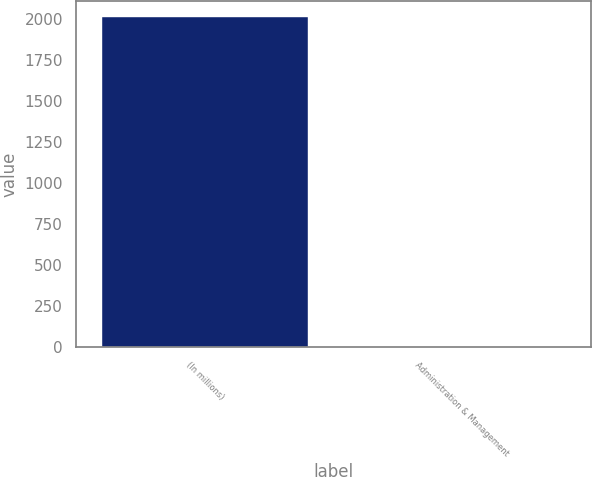Convert chart. <chart><loc_0><loc_0><loc_500><loc_500><bar_chart><fcel>(In millions)<fcel>Administration & Management<nl><fcel>2007<fcel>1.6<nl></chart> 